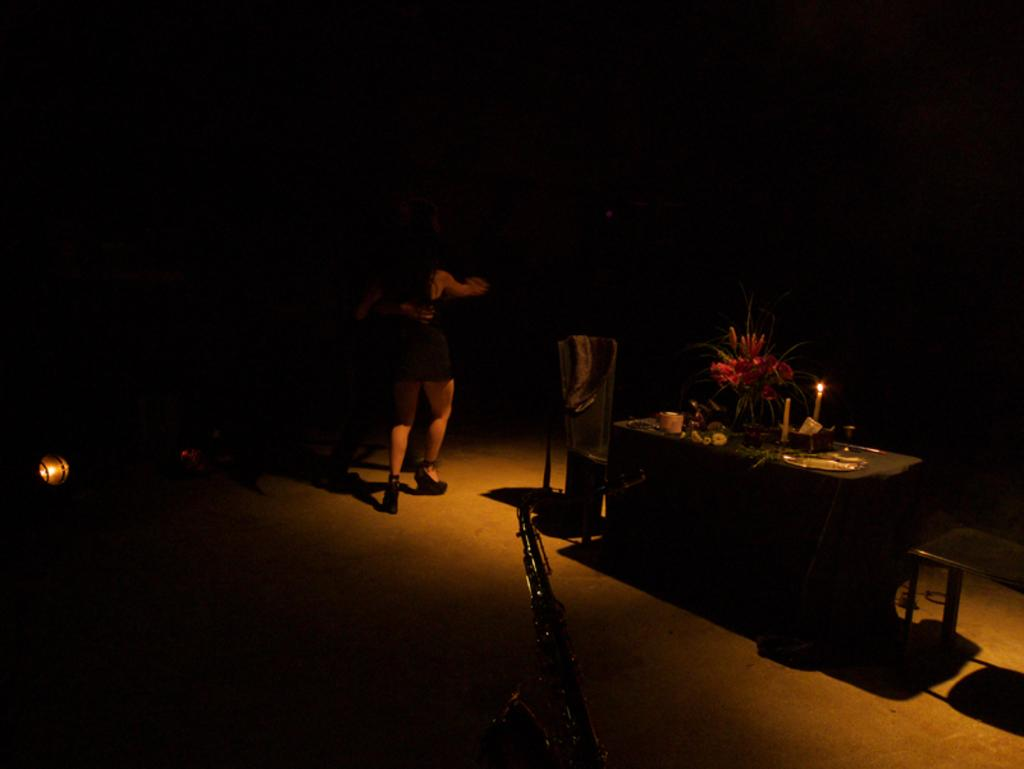What object is present in the image that typically holds flowers? There is a flower vase in the image. What can be seen on the table in the image? There are candles on the table in the image. What type of furniture is visible in the image? There are chairs in the image. What activity are the man and woman engaged in? The man and woman appear to be dancing in the image. Where is the rose located in the image? There is no rose present in the image. What type of animal can be seen walking around the dancing couple in the image? There are no animals, including chickens, present in the image. 